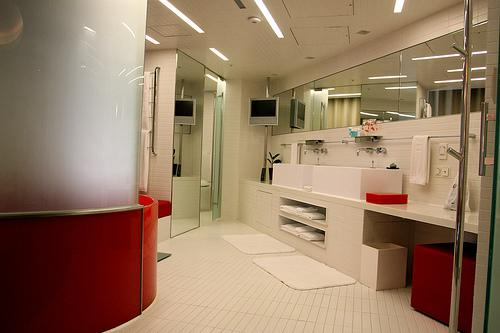Question: what room in the house is this?
Choices:
A. Bedroom.
B. Living room.
C. Bathroom.
D. Basement.
Answer with the letter. Answer: C Question: what type of floor is in this room?
Choices:
A. Laminate.
B. Cement.
C. Hardwood.
D. Tile.
Answer with the letter. Answer: D Question: what color are the sinks?
Choices:
A. Black.
B. Silver.
C. Cream.
D. White.
Answer with the letter. Answer: D 